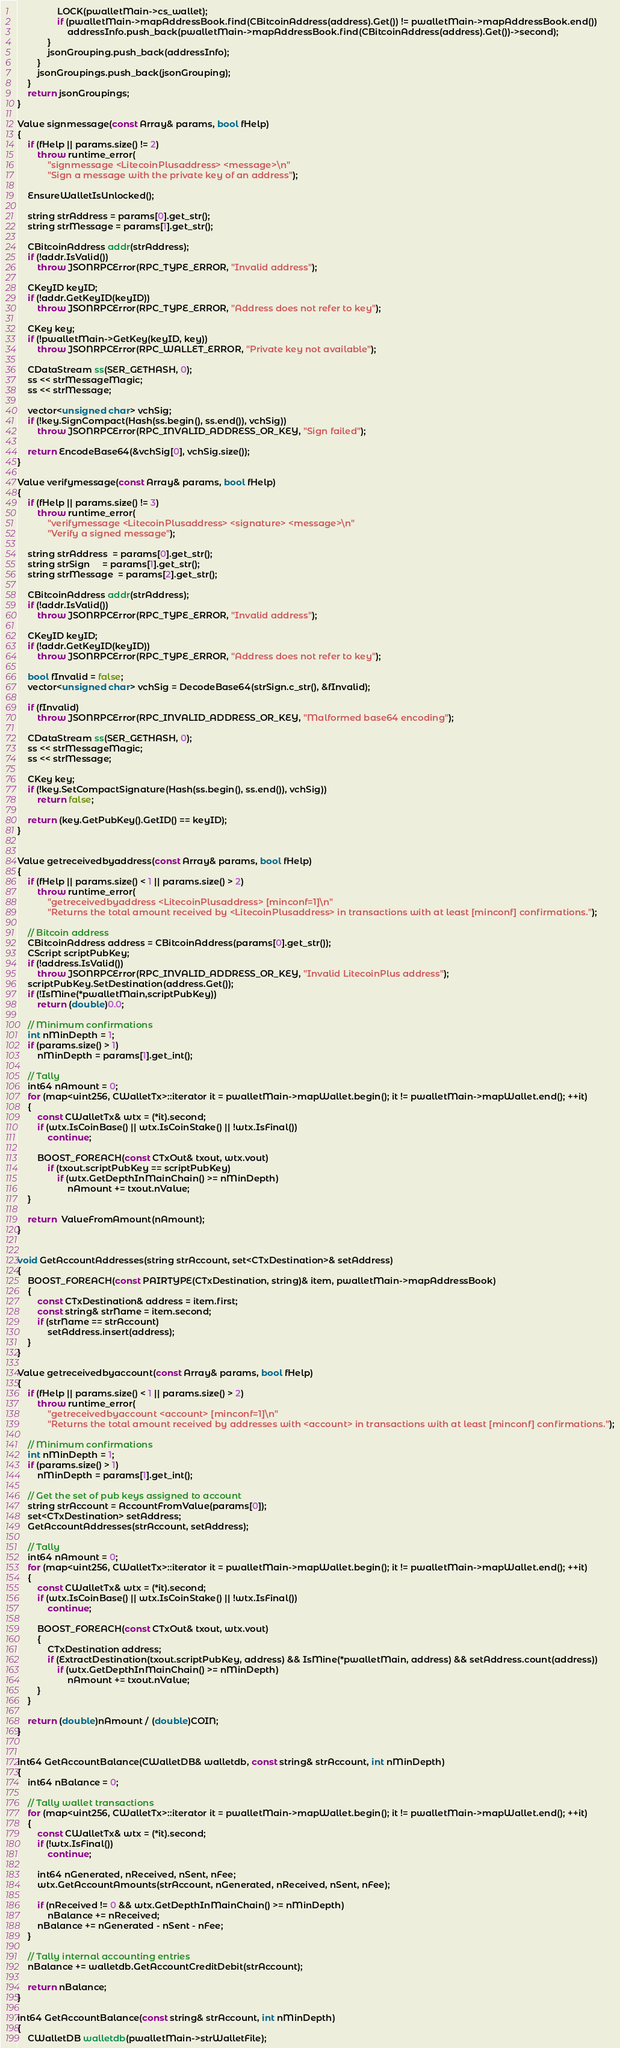<code> <loc_0><loc_0><loc_500><loc_500><_C++_>                LOCK(pwalletMain->cs_wallet);
                if (pwalletMain->mapAddressBook.find(CBitcoinAddress(address).Get()) != pwalletMain->mapAddressBook.end())
                    addressInfo.push_back(pwalletMain->mapAddressBook.find(CBitcoinAddress(address).Get())->second);
            }
            jsonGrouping.push_back(addressInfo);
        }
        jsonGroupings.push_back(jsonGrouping);
    }
    return jsonGroupings;
}

Value signmessage(const Array& params, bool fHelp)
{
    if (fHelp || params.size() != 2)
        throw runtime_error(
            "signmessage <LitecoinPlusaddress> <message>\n"
            "Sign a message with the private key of an address");

    EnsureWalletIsUnlocked();

    string strAddress = params[0].get_str();
    string strMessage = params[1].get_str();

    CBitcoinAddress addr(strAddress);
    if (!addr.IsValid())
        throw JSONRPCError(RPC_TYPE_ERROR, "Invalid address");

    CKeyID keyID;
    if (!addr.GetKeyID(keyID))
        throw JSONRPCError(RPC_TYPE_ERROR, "Address does not refer to key");

    CKey key;
    if (!pwalletMain->GetKey(keyID, key))
        throw JSONRPCError(RPC_WALLET_ERROR, "Private key not available");

    CDataStream ss(SER_GETHASH, 0);
    ss << strMessageMagic;
    ss << strMessage;

    vector<unsigned char> vchSig;
    if (!key.SignCompact(Hash(ss.begin(), ss.end()), vchSig))
        throw JSONRPCError(RPC_INVALID_ADDRESS_OR_KEY, "Sign failed");

    return EncodeBase64(&vchSig[0], vchSig.size());
}

Value verifymessage(const Array& params, bool fHelp)
{
    if (fHelp || params.size() != 3)
        throw runtime_error(
            "verifymessage <LitecoinPlusaddress> <signature> <message>\n"
            "Verify a signed message");

    string strAddress  = params[0].get_str();
    string strSign     = params[1].get_str();
    string strMessage  = params[2].get_str();

    CBitcoinAddress addr(strAddress);
    if (!addr.IsValid())
        throw JSONRPCError(RPC_TYPE_ERROR, "Invalid address");

    CKeyID keyID;
    if (!addr.GetKeyID(keyID))
        throw JSONRPCError(RPC_TYPE_ERROR, "Address does not refer to key");

    bool fInvalid = false;
    vector<unsigned char> vchSig = DecodeBase64(strSign.c_str(), &fInvalid);

    if (fInvalid)
        throw JSONRPCError(RPC_INVALID_ADDRESS_OR_KEY, "Malformed base64 encoding");

    CDataStream ss(SER_GETHASH, 0);
    ss << strMessageMagic;
    ss << strMessage;

    CKey key;
    if (!key.SetCompactSignature(Hash(ss.begin(), ss.end()), vchSig))
        return false;

    return (key.GetPubKey().GetID() == keyID);
}


Value getreceivedbyaddress(const Array& params, bool fHelp)
{
    if (fHelp || params.size() < 1 || params.size() > 2)
        throw runtime_error(
            "getreceivedbyaddress <LitecoinPlusaddress> [minconf=1]\n"
            "Returns the total amount received by <LitecoinPlusaddress> in transactions with at least [minconf] confirmations.");

    // Bitcoin address
    CBitcoinAddress address = CBitcoinAddress(params[0].get_str());
    CScript scriptPubKey;
    if (!address.IsValid())
        throw JSONRPCError(RPC_INVALID_ADDRESS_OR_KEY, "Invalid LitecoinPlus address");
    scriptPubKey.SetDestination(address.Get());
    if (!IsMine(*pwalletMain,scriptPubKey))
        return (double)0.0;

    // Minimum confirmations
    int nMinDepth = 1;
    if (params.size() > 1)
        nMinDepth = params[1].get_int();

    // Tally
    int64 nAmount = 0;
    for (map<uint256, CWalletTx>::iterator it = pwalletMain->mapWallet.begin(); it != pwalletMain->mapWallet.end(); ++it)
    {
        const CWalletTx& wtx = (*it).second;
        if (wtx.IsCoinBase() || wtx.IsCoinStake() || !wtx.IsFinal())
            continue;

        BOOST_FOREACH(const CTxOut& txout, wtx.vout)
            if (txout.scriptPubKey == scriptPubKey)
                if (wtx.GetDepthInMainChain() >= nMinDepth)
                    nAmount += txout.nValue;
    }

    return  ValueFromAmount(nAmount);
}


void GetAccountAddresses(string strAccount, set<CTxDestination>& setAddress)
{
    BOOST_FOREACH(const PAIRTYPE(CTxDestination, string)& item, pwalletMain->mapAddressBook)
    {
        const CTxDestination& address = item.first;
        const string& strName = item.second;
        if (strName == strAccount)
            setAddress.insert(address);
    }
}

Value getreceivedbyaccount(const Array& params, bool fHelp)
{
    if (fHelp || params.size() < 1 || params.size() > 2)
        throw runtime_error(
            "getreceivedbyaccount <account> [minconf=1]\n"
            "Returns the total amount received by addresses with <account> in transactions with at least [minconf] confirmations.");

    // Minimum confirmations
    int nMinDepth = 1;
    if (params.size() > 1)
        nMinDepth = params[1].get_int();

    // Get the set of pub keys assigned to account
    string strAccount = AccountFromValue(params[0]);
    set<CTxDestination> setAddress;
    GetAccountAddresses(strAccount, setAddress);

    // Tally
    int64 nAmount = 0;
    for (map<uint256, CWalletTx>::iterator it = pwalletMain->mapWallet.begin(); it != pwalletMain->mapWallet.end(); ++it)
    {
        const CWalletTx& wtx = (*it).second;
        if (wtx.IsCoinBase() || wtx.IsCoinStake() || !wtx.IsFinal())
            continue;

        BOOST_FOREACH(const CTxOut& txout, wtx.vout)
        {
            CTxDestination address;
            if (ExtractDestination(txout.scriptPubKey, address) && IsMine(*pwalletMain, address) && setAddress.count(address))
                if (wtx.GetDepthInMainChain() >= nMinDepth)
                    nAmount += txout.nValue;
        }
    }

    return (double)nAmount / (double)COIN;
}


int64 GetAccountBalance(CWalletDB& walletdb, const string& strAccount, int nMinDepth)
{
    int64 nBalance = 0;

    // Tally wallet transactions
    for (map<uint256, CWalletTx>::iterator it = pwalletMain->mapWallet.begin(); it != pwalletMain->mapWallet.end(); ++it)
    {
        const CWalletTx& wtx = (*it).second;
        if (!wtx.IsFinal())
            continue;

        int64 nGenerated, nReceived, nSent, nFee;
        wtx.GetAccountAmounts(strAccount, nGenerated, nReceived, nSent, nFee);

        if (nReceived != 0 && wtx.GetDepthInMainChain() >= nMinDepth)
            nBalance += nReceived;
        nBalance += nGenerated - nSent - nFee;
    }

    // Tally internal accounting entries
    nBalance += walletdb.GetAccountCreditDebit(strAccount);

    return nBalance;
}

int64 GetAccountBalance(const string& strAccount, int nMinDepth)
{
    CWalletDB walletdb(pwalletMain->strWalletFile);</code> 